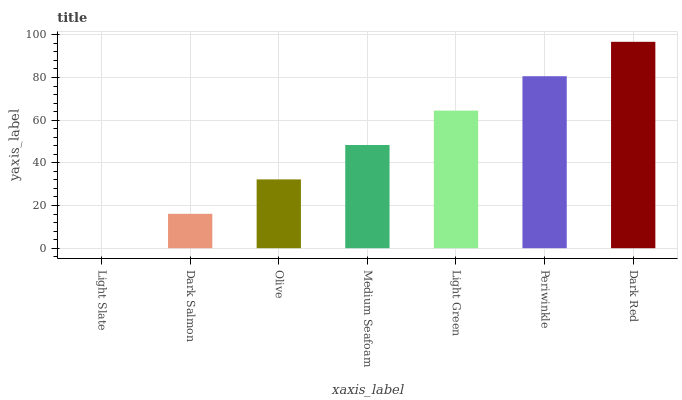Is Light Slate the minimum?
Answer yes or no. Yes. Is Dark Red the maximum?
Answer yes or no. Yes. Is Dark Salmon the minimum?
Answer yes or no. No. Is Dark Salmon the maximum?
Answer yes or no. No. Is Dark Salmon greater than Light Slate?
Answer yes or no. Yes. Is Light Slate less than Dark Salmon?
Answer yes or no. Yes. Is Light Slate greater than Dark Salmon?
Answer yes or no. No. Is Dark Salmon less than Light Slate?
Answer yes or no. No. Is Medium Seafoam the high median?
Answer yes or no. Yes. Is Medium Seafoam the low median?
Answer yes or no. Yes. Is Periwinkle the high median?
Answer yes or no. No. Is Olive the low median?
Answer yes or no. No. 